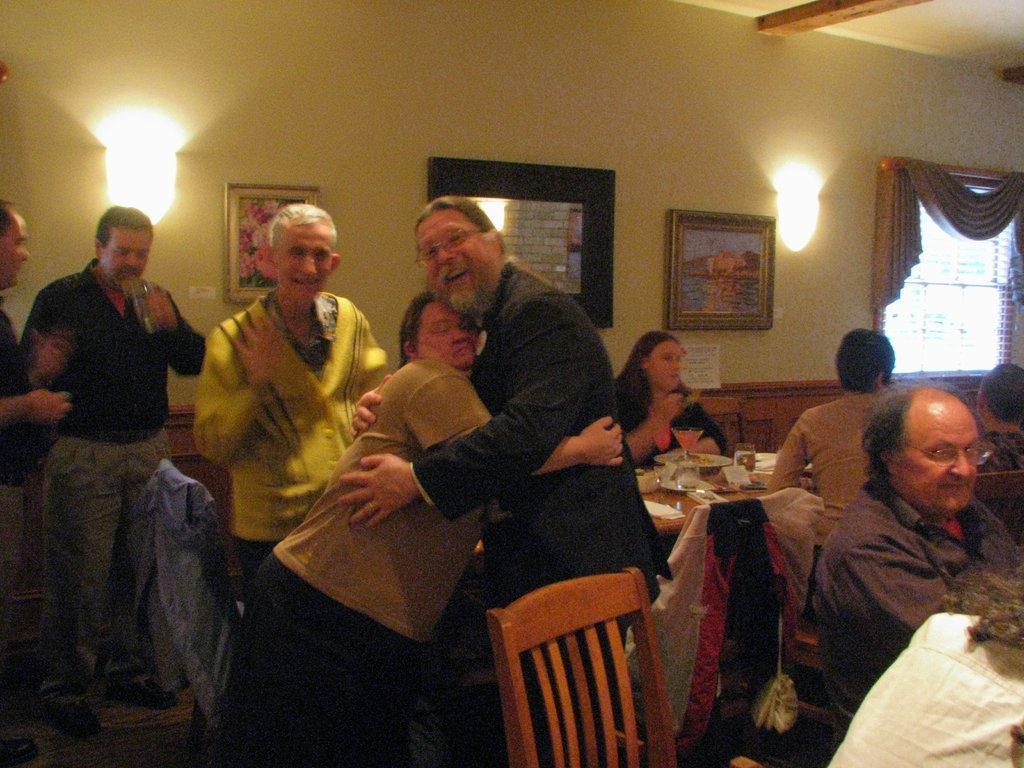Please provide a concise description of this image. In this image I can see the group of people with different color dresses. There is a table in-front of few people. On the table I can see the plates with food, glasses, boards and few objects. In the background I can see the lights, frames and the window to the wall. I can see the curtain to the window. 